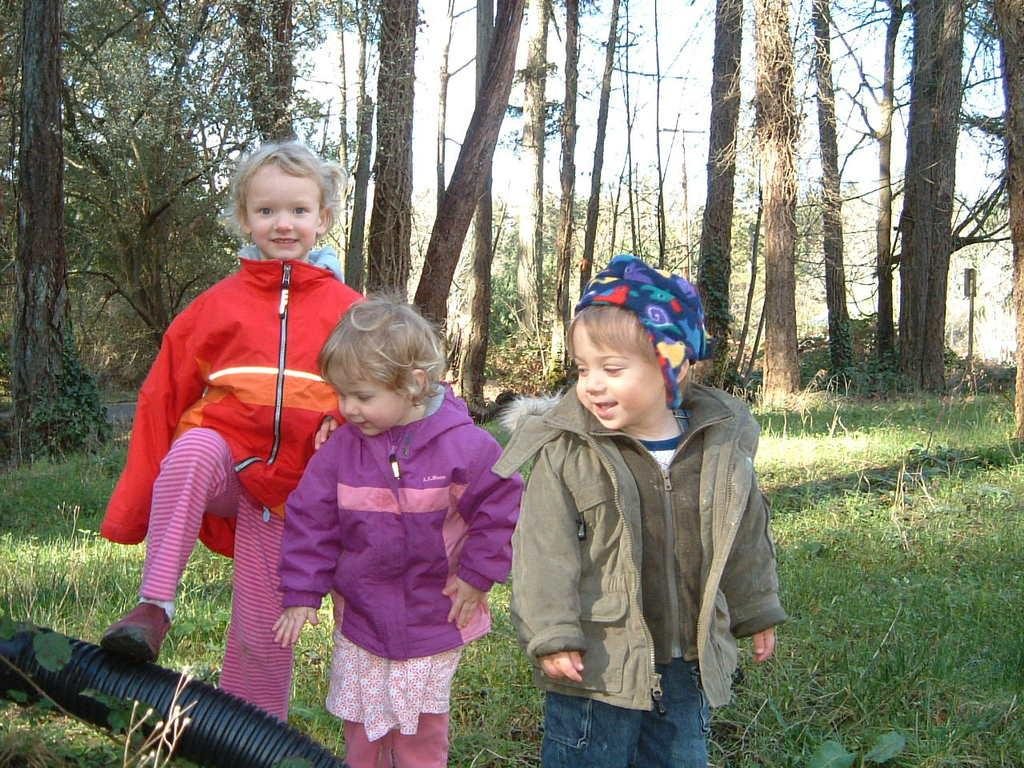How many kids are present in the image? There are three kids standing in the image. What else can be seen in the image besides the kids? There is a pipe visible in the image. What type of natural environment is present in the image? There is grass in the image, and trees can be seen in the background. What is visible in the background of the image? The sky is visible in the background of the image. What type of floor design can be seen in the image? There is no floor visible in the image, so it is not possible to determine the design of any floor. 